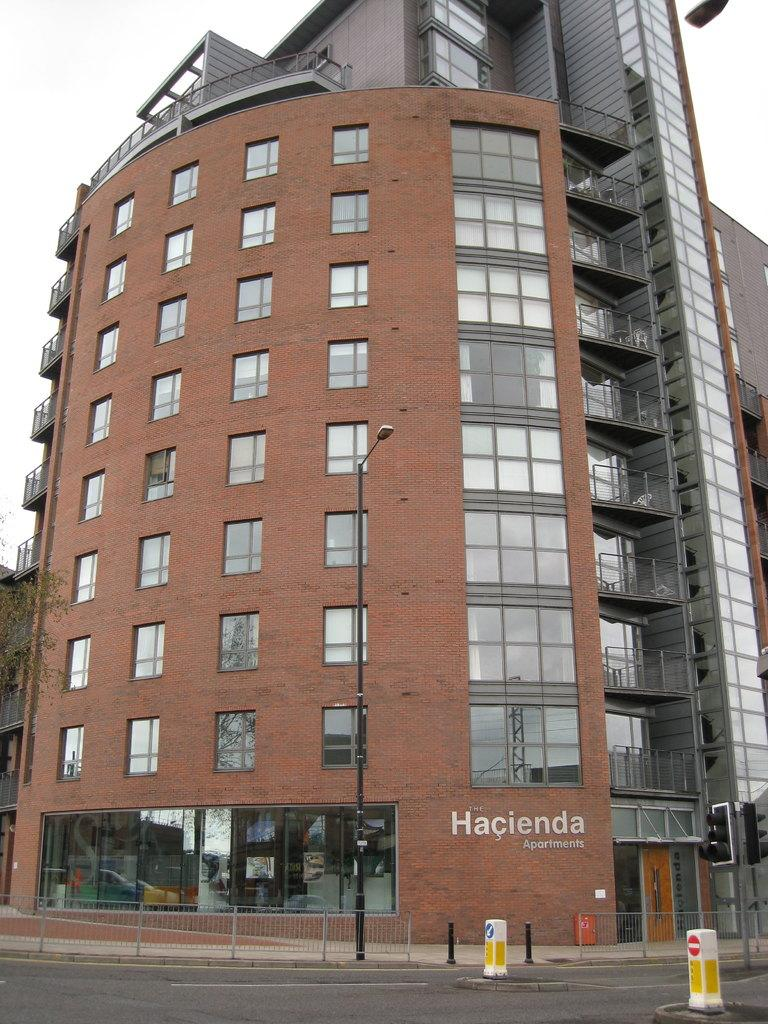<image>
Share a concise interpretation of the image provided. an apartment complex by the name of 'hacienda apartments' 